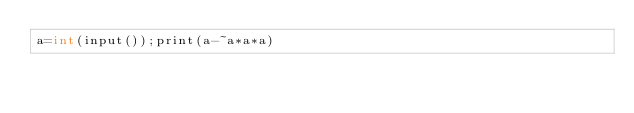Convert code to text. <code><loc_0><loc_0><loc_500><loc_500><_Cython_>a=int(input());print(a-~a*a*a)</code> 